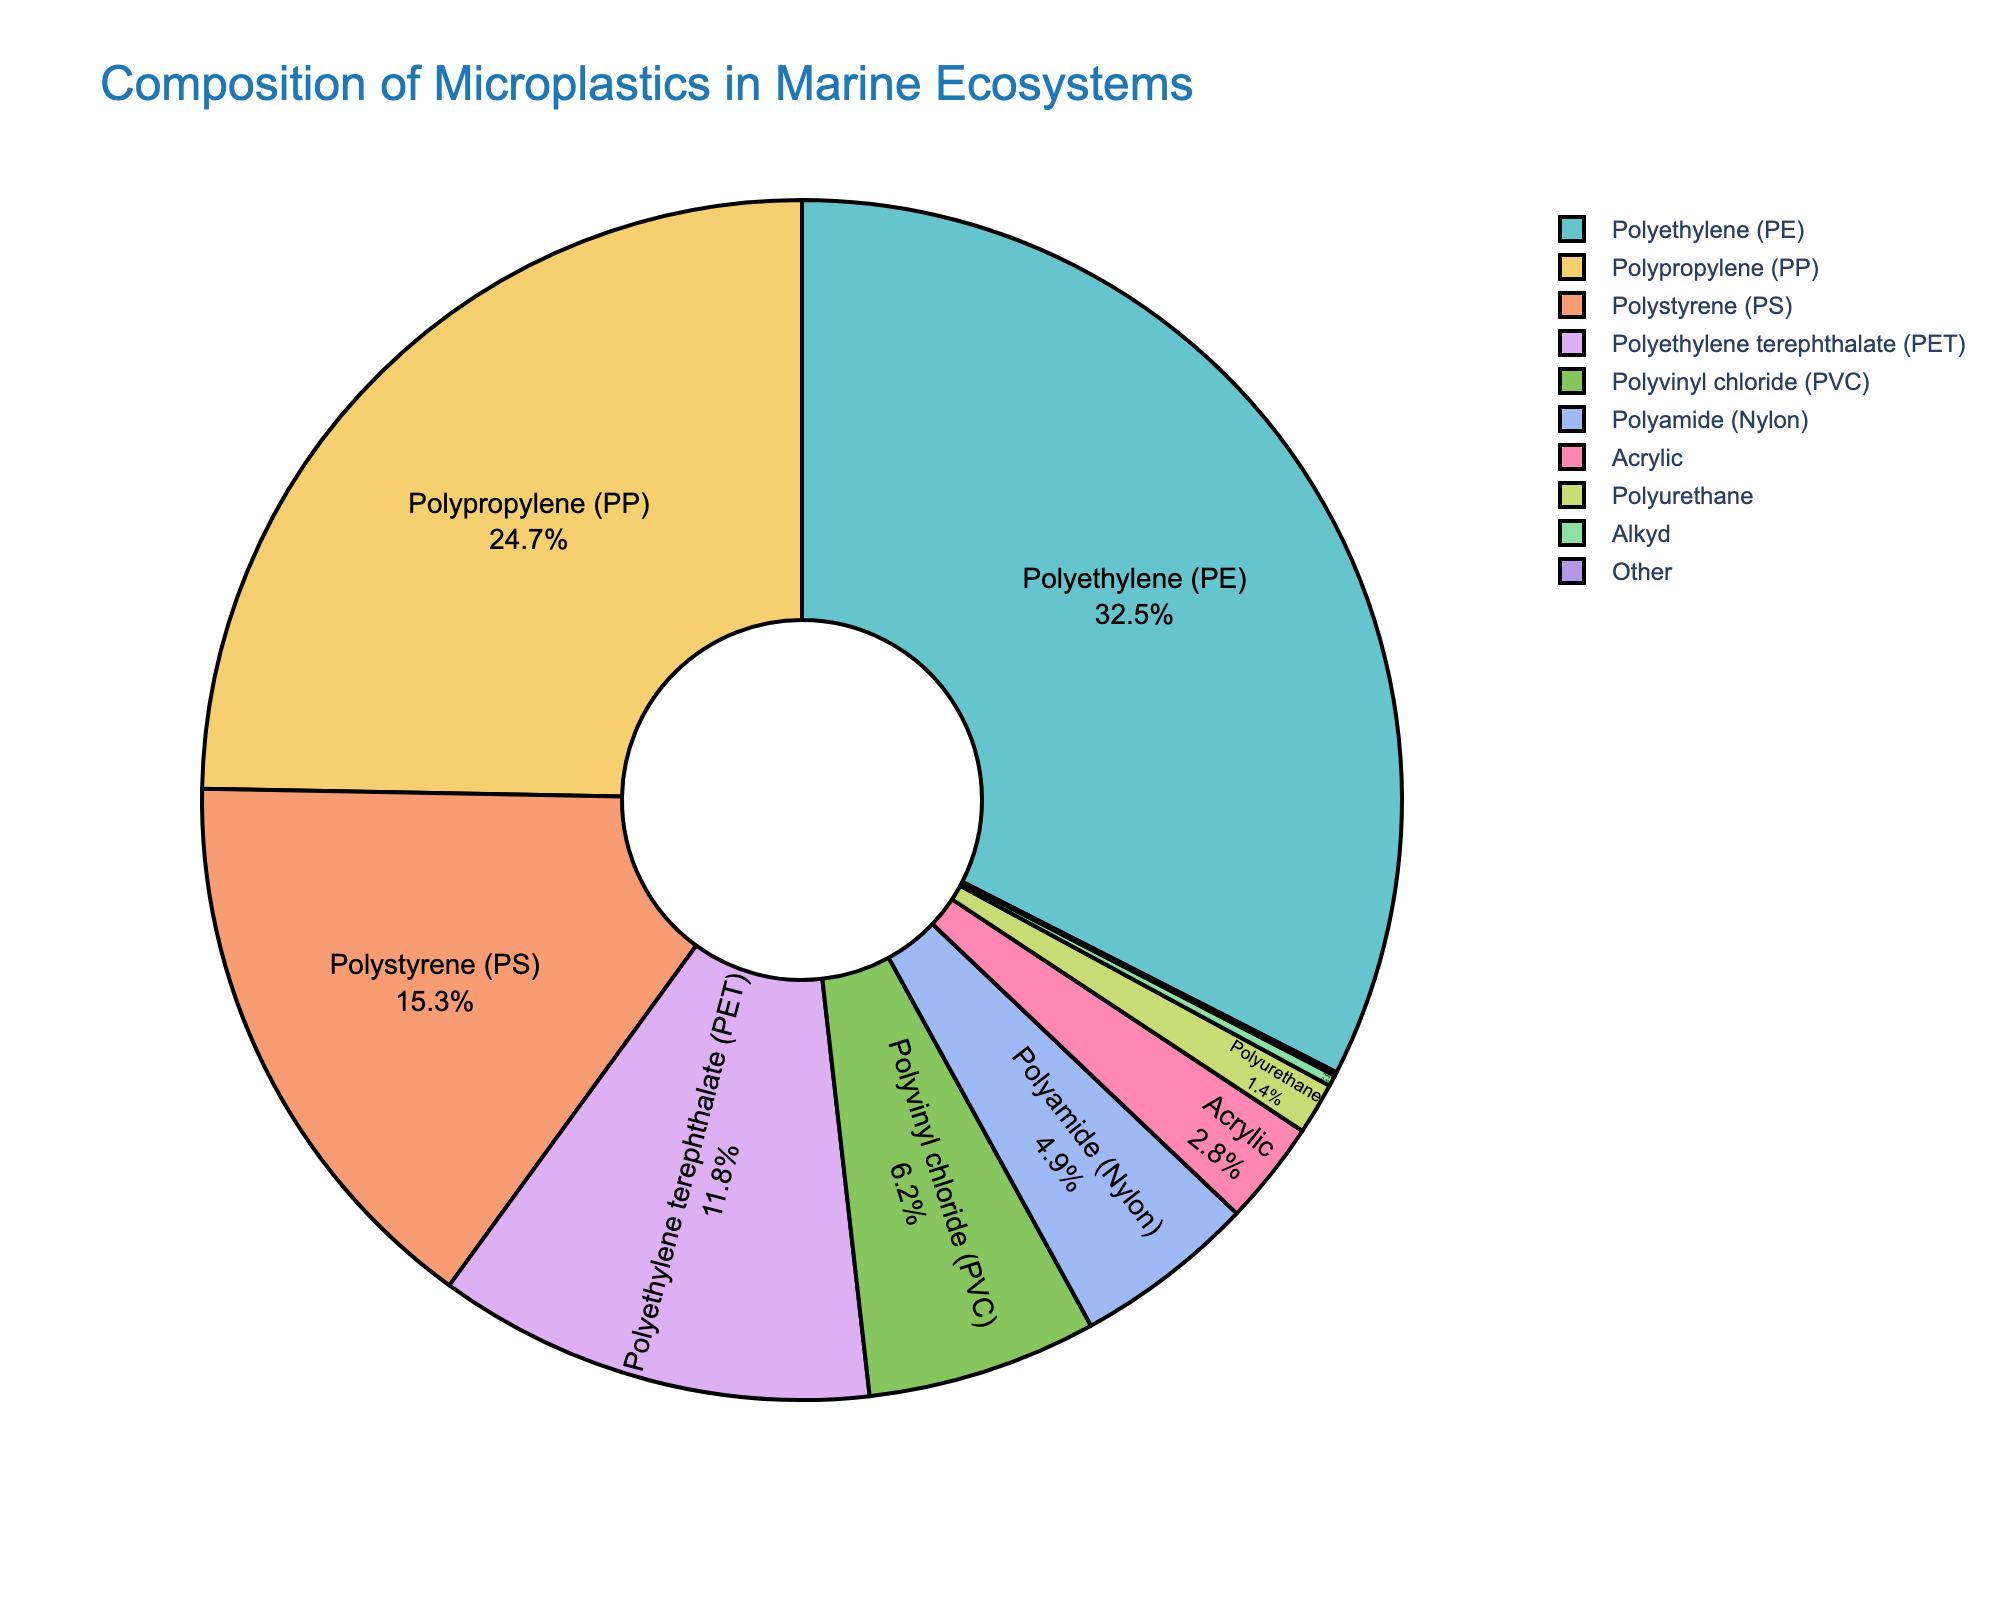What percentage of the microplastics is composed of Polypropylene (PP) and Polystyrene (PS) combined? To find the combined percentage, sum the individual percentages of PP and PS. PP contributes 24.7% and PS contributes 15.3%. Adding these gives 24.7% + 15.3% = 40%.
Answer: 40% Which type of microplastic has the smallest contribution to the total composition? Observe the pie chart and look for the smallest segment. The "Other" category has the smallest slice of the pie chart with 0.1%.
Answer: Other Is Polyethylene (PE) percentage greater than twice the percentage of Polyamide (Nylon)? Compare the percentage values: twice the Polyamide (Nylon) percentage is 2 * 4.9% = 9.8%. Polyethylene (PE) has a value of 32.5%, which is greater than 9.8%.
Answer: Yes Which microplastic types have a contribution between 5% and 20%? Check which segments fall within the specified range. Polystyrene (PS) at 15.3%, Polyethylene terephthalate (PET) at 11.8%, and Polyvinyl chloride (PVC) at 6.2% are all within this range.
Answer: PS, PET, PVC Does Polyethylene (PE) have a larger share than Polypropylene (PP) and PET combined? Compare the values: PE is 32.5%, while PP + PET is 24.7% + 11.8% = 36.5%. Thus, PE does not have a larger share than PP and PET combined.
Answer: No What is the total percentage of microplastics contributed by synthetic fibers (Nylon, Acrylic, and Alkyd)? Add the percentages of Polyamide (Nylon), Acrylic, and Alkyd. Nylon is 4.9%, Acrylic is 2.8%, and Alkyd is 0.3%. The sum is 4.9% + 2.8% + 0.3% = 8%.
Answer: 8% Which is more prevalent, Polyvinyl chloride (PVC) or Polyurethane? Compare the individual values. PVC has 6.2%, whereas Polyurethane has 1.4%. PVC is more prevalent.
Answer: PVC How much larger is the percentage of Polyethylene (PE) compared to Polyvinyl chloride (PVC)? Subtract the percentage of PVC from the percentage of PE. PE is 32.5% and PVC is 6.2%, so the difference is 32.5% - 6.2% = 26.3%.
Answer: 26.3% What fraction of the pie chart is represented by the four least common types of microplastics? Identify the four least common types: Polyurethane (1.4%), Alkyd (0.3%), Other (0.1%), and Acrylic (2.8%). Add these percentages: 1.4% + 0.3% + 0.1% + 2.8% = 4.6%.
Answer: 4.6% What percentage does the most common microplastic contribute relative to the second most common type? The most common is Polyethylene (PE) at 32.5% and the second most common is Polypropylene (PP) at 24.7%. Relative percentage is (32.5% / 24.7%) * 100 = ~131.58%.
Answer: ~131.58% 